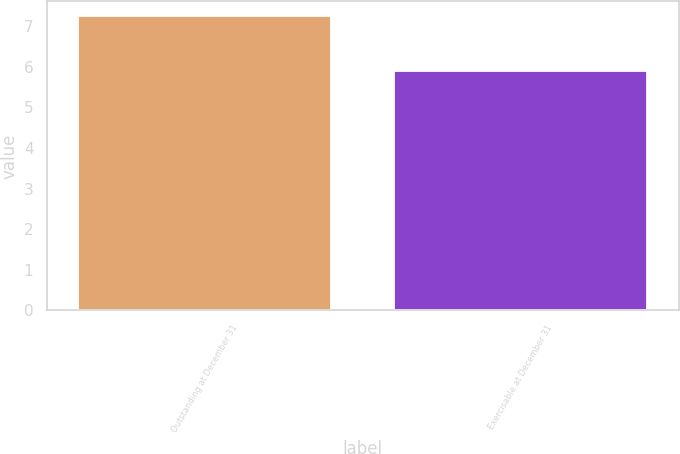Convert chart to OTSL. <chart><loc_0><loc_0><loc_500><loc_500><bar_chart><fcel>Outstanding at December 31<fcel>Exercisable at December 31<nl><fcel>7.25<fcel>5.9<nl></chart> 